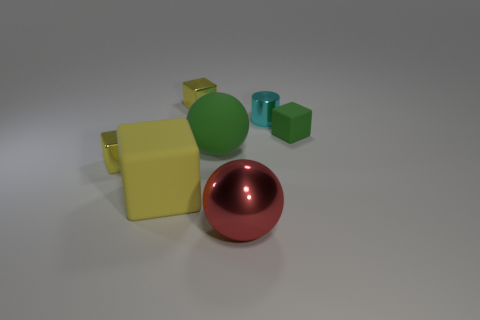Is there anything else that is the same shape as the large green thing?
Ensure brevity in your answer.  Yes. What shape is the small cyan thing that is the same material as the red sphere?
Your answer should be very brief. Cylinder. Are there the same number of rubber spheres in front of the large green object and green spheres?
Provide a succinct answer. No. Is the material of the cube that is to the right of the cylinder the same as the small object to the left of the big yellow matte thing?
Give a very brief answer. No. What is the shape of the tiny thing that is in front of the big sphere that is behind the large block?
Offer a very short reply. Cube. What is the color of the block that is made of the same material as the tiny green thing?
Keep it short and to the point. Yellow. Is the metallic cylinder the same color as the small matte object?
Provide a succinct answer. No. The green thing that is the same size as the cyan cylinder is what shape?
Your answer should be very brief. Cube. What is the size of the red ball?
Offer a very short reply. Large. There is a yellow metal object behind the green ball; does it have the same size as the matte object that is on the right side of the big shiny ball?
Ensure brevity in your answer.  Yes. 